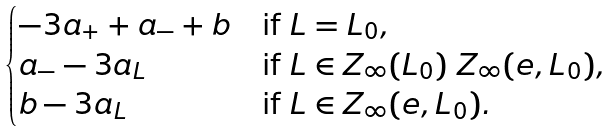Convert formula to latex. <formula><loc_0><loc_0><loc_500><loc_500>\begin{cases} - 3 a _ { + } + a _ { - } + b & \text {if $L=L_{0}$} , \\ a _ { - } - 3 a _ { L } & \text {if ${L}\in{Z_{\infty}(L_{0})}\ Z_{\infty}(e,L_{0})$} , \\ b - 3 a _ { L } & \text {if ${L}\in{Z_{\infty}(e,L_{0})}$} . \end{cases}</formula> 